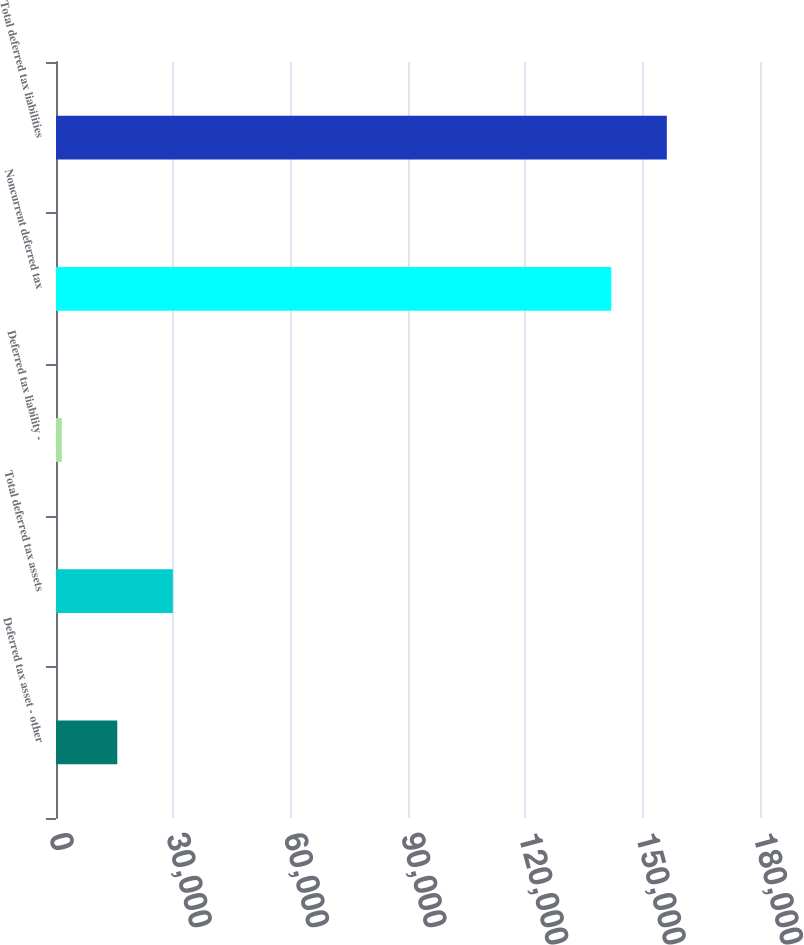Convert chart to OTSL. <chart><loc_0><loc_0><loc_500><loc_500><bar_chart><fcel>Deferred tax asset - other<fcel>Total deferred tax assets<fcel>Deferred tax liability -<fcel>Noncurrent deferred tax<fcel>Total deferred tax liabilities<nl><fcel>15669.4<fcel>29867.8<fcel>1471<fcel>141984<fcel>156182<nl></chart> 